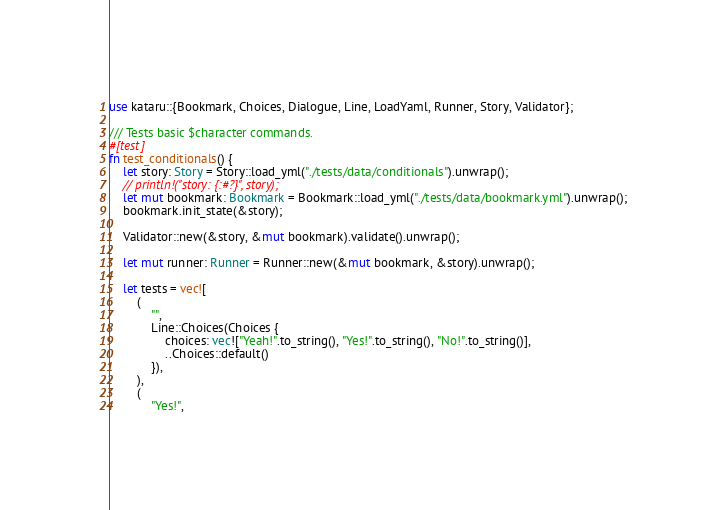Convert code to text. <code><loc_0><loc_0><loc_500><loc_500><_Rust_>use kataru::{Bookmark, Choices, Dialogue, Line, LoadYaml, Runner, Story, Validator};

/// Tests basic $character commands.
#[test]
fn test_conditionals() {
    let story: Story = Story::load_yml("./tests/data/conditionals").unwrap();
    // println!("story: {:#?}", story);
    let mut bookmark: Bookmark = Bookmark::load_yml("./tests/data/bookmark.yml").unwrap();
    bookmark.init_state(&story);

    Validator::new(&story, &mut bookmark).validate().unwrap();

    let mut runner: Runner = Runner::new(&mut bookmark, &story).unwrap();

    let tests = vec![
        (
            "",
            Line::Choices(Choices {
                choices: vec!["Yeah!".to_string(), "Yes!".to_string(), "No!".to_string()],
                ..Choices::default()
            }),
        ),
        (
            "Yes!",</code> 